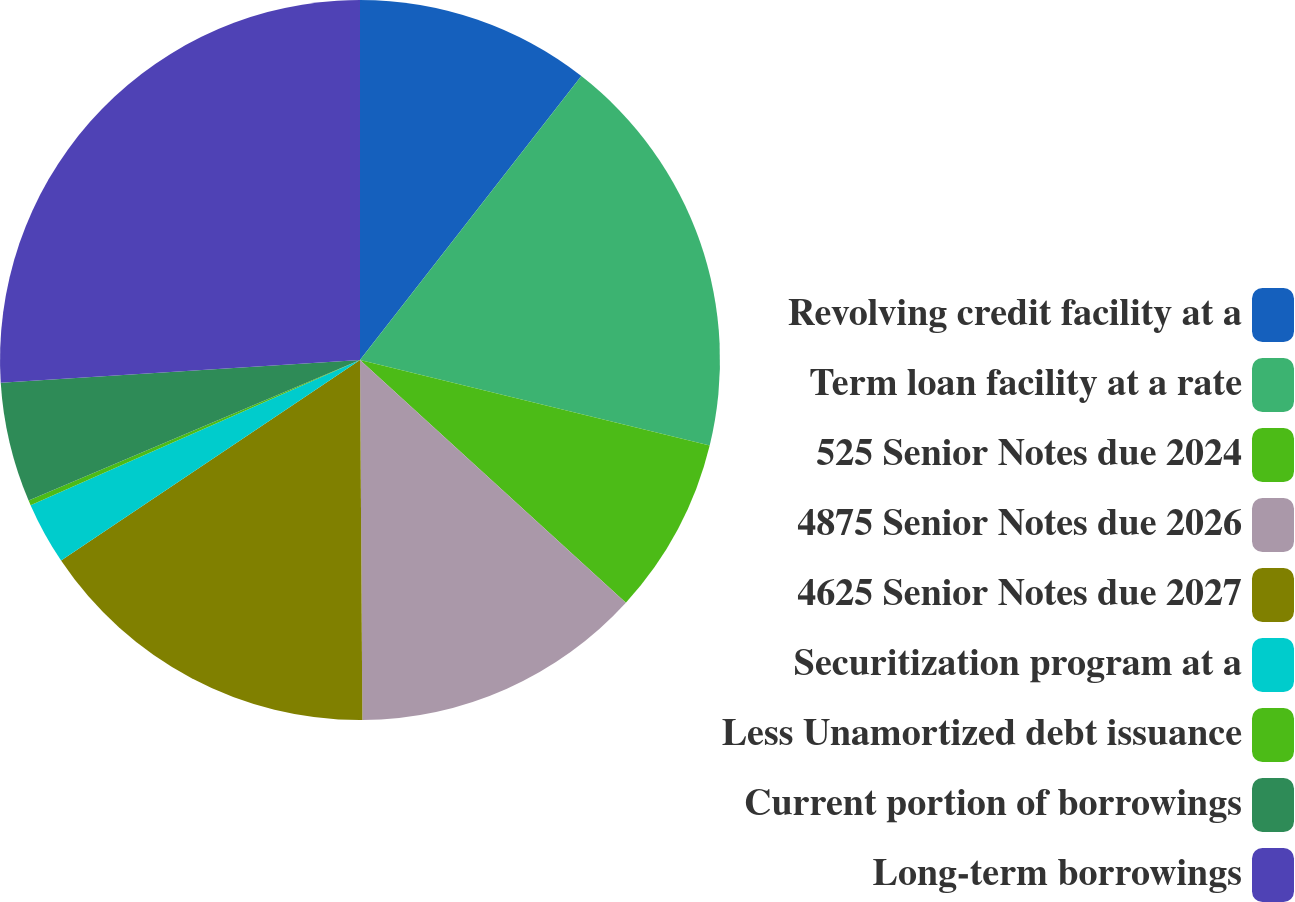Convert chart to OTSL. <chart><loc_0><loc_0><loc_500><loc_500><pie_chart><fcel>Revolving credit facility at a<fcel>Term loan facility at a rate<fcel>525 Senior Notes due 2024<fcel>4875 Senior Notes due 2026<fcel>4625 Senior Notes due 2027<fcel>Securitization program at a<fcel>Less Unamortized debt issuance<fcel>Current portion of borrowings<fcel>Long-term borrowings<nl><fcel>10.54%<fcel>18.28%<fcel>7.96%<fcel>13.12%<fcel>15.7%<fcel>2.8%<fcel>0.22%<fcel>5.38%<fcel>26.01%<nl></chart> 